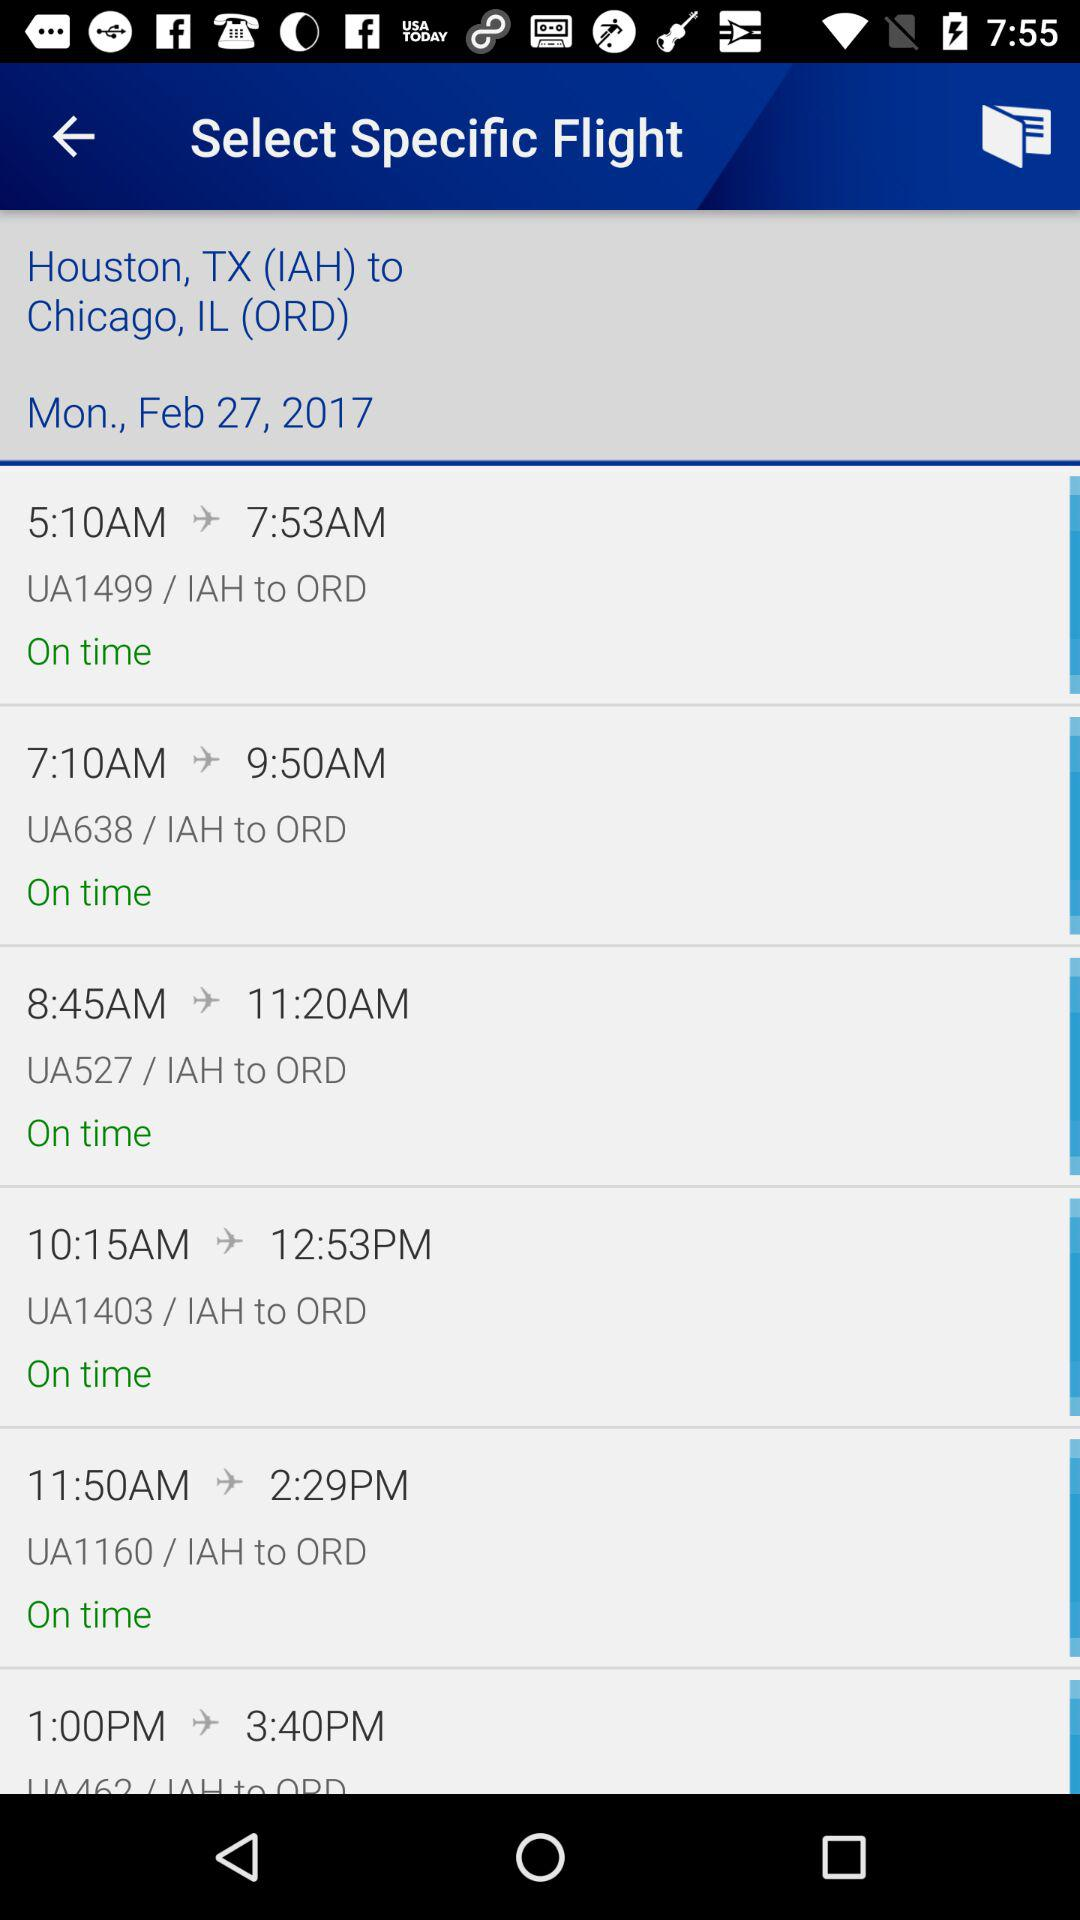What is the departure time of the flight "UA1499"? The departure time of the flight "UA1499" is 5:10 AM. 